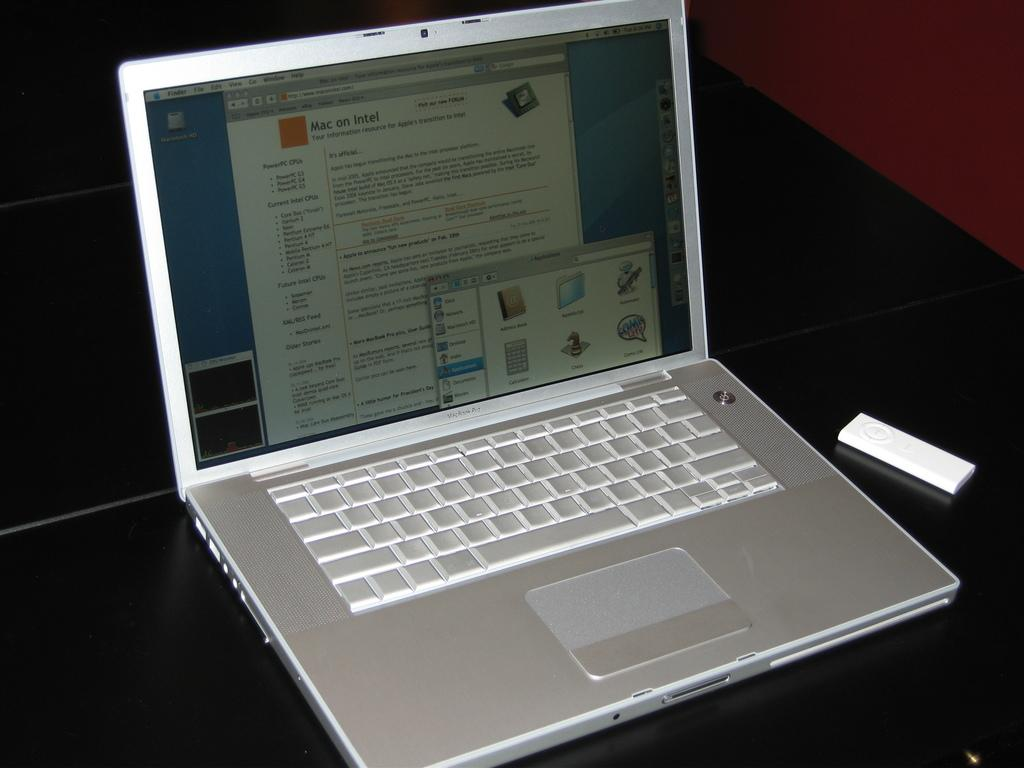<image>
Create a compact narrative representing the image presented. a silver macbook pro with an open page that says 'mac on intel' 